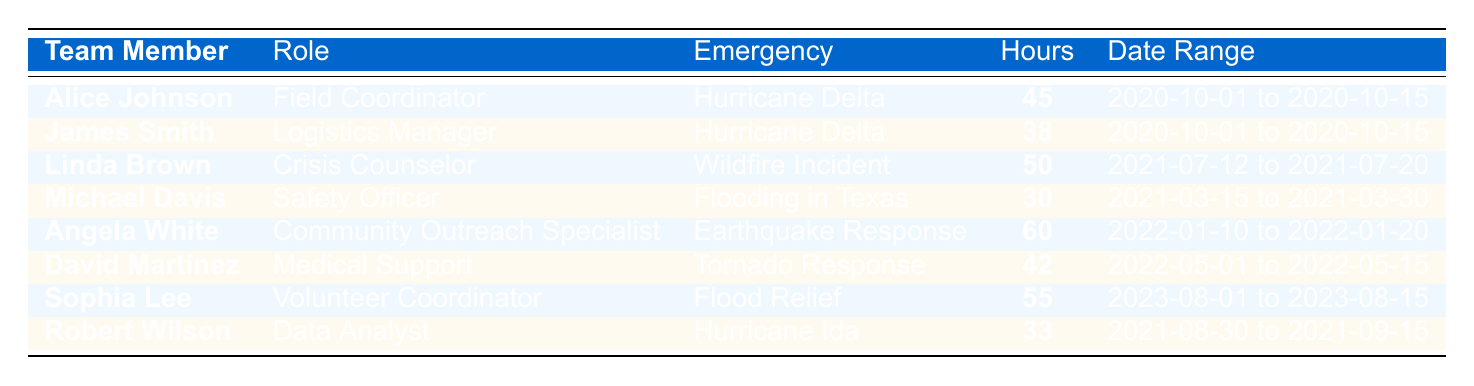What is the total number of hours logged by all team members? To find the total hours, I sum all the hours logged: 45 + 38 + 50 + 30 + 60 + 42 + 55 + 33 = 353 hours.
Answer: 353 hours Who logged the highest number of hours and how many? I check each team member's hours and see that Angela White logged the highest with 60 hours.
Answer: Angela White, 60 hours How many team members contributed to the Hurricane Delta emergency? By counting the entries for Hurricane Delta, I find that there are 2 team members: Alice Johnson and James Smith.
Answer: 2 team members What is the difference between the highest and lowest hours logged? The highest hours logged is 60 (Angela White) and the lowest is 30 (Michael Davis), so the difference is 60 - 30 = 30 hours.
Answer: 30 hours Is Linda Brown a Field Coordinator? By checking the role listed for Linda Brown, I see she is a Crisis Counselor, not a Field Coordinator.
Answer: No What is the average number of hours logged for the entire group? To find the average, I sum the hours (353) and divide by the number of team members (8). The average is 353 / 8 = 44.125 hours.
Answer: 44.125 hours How many team members logged more than 40 hours? I look through the table and count the team members who logged more than 40 hours: Alice Johnson, Linda Brown, Angela White, David Martinez, and Sophia Lee. There are 5 members.
Answer: 5 team members Which emergency had the most hours logged and how many? I compare hours logged for each emergency: Hurricane Delta (83), Wildfire Incident (50), Flooding in Texas (30), Earthquake Response (60), Tornado Response (42), Flood Relief (55), and Hurricane Ida (33). Hurricane Delta has the most with 83 hours.
Answer: Hurricane Delta, 83 hours Count the number of different roles represented in the table. I list the unique roles: Field Coordinator, Logistics Manager, Crisis Counselor, Safety Officer, Community Outreach Specialist, Medical Support, Volunteer Coordinator, and Data Analyst. That gives me 8 different roles.
Answer: 8 roles Did James Smith work on the Flood Relief operation? Checking the entries, James Smith is listed as a Logistics Manager for Hurricane Delta and not for Flood Relief.
Answer: No 